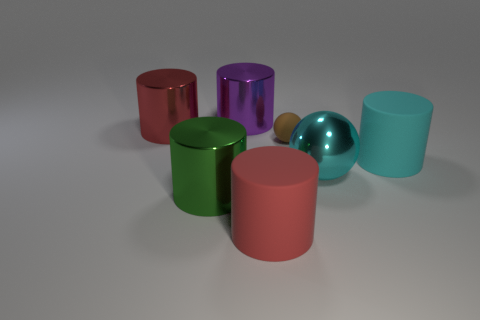There is a metal object on the right side of the purple thing; what is its color?
Make the answer very short. Cyan. There is a big matte object to the left of the small ball; are there any large metal balls left of it?
Provide a short and direct response. No. There is a tiny thing; is it the same color as the matte thing in front of the large cyan metallic thing?
Offer a terse response. No. Are there any big brown objects that have the same material as the purple thing?
Give a very brief answer. No. How many green shiny cylinders are there?
Give a very brief answer. 1. There is a red thing that is left of the thing behind the big red metallic thing; what is its material?
Your answer should be very brief. Metal. What is the color of the ball that is the same material as the purple thing?
Offer a terse response. Cyan. What is the shape of the rubber thing that is the same color as the large metal ball?
Your answer should be very brief. Cylinder. Is the size of the red thing that is left of the large purple metal cylinder the same as the cylinder that is on the right side of the brown rubber sphere?
Your answer should be compact. Yes. What number of cylinders are either big purple metallic objects or big green metallic objects?
Your answer should be very brief. 2. 